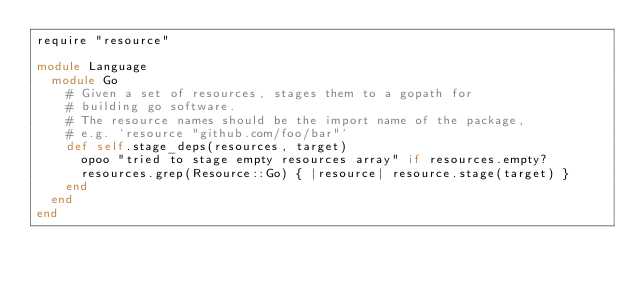Convert code to text. <code><loc_0><loc_0><loc_500><loc_500><_Ruby_>require "resource"

module Language
  module Go
    # Given a set of resources, stages them to a gopath for
    # building go software.
    # The resource names should be the import name of the package,
    # e.g. `resource "github.com/foo/bar"`
    def self.stage_deps(resources, target)
      opoo "tried to stage empty resources array" if resources.empty?
      resources.grep(Resource::Go) { |resource| resource.stage(target) }
    end
  end
end
</code> 